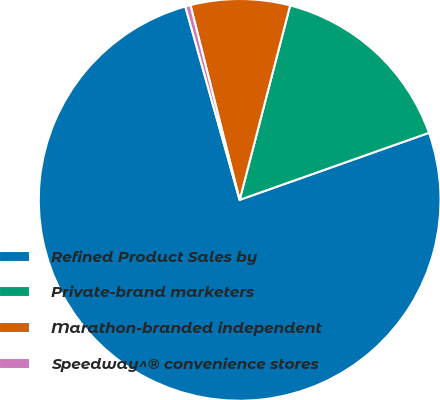<chart> <loc_0><loc_0><loc_500><loc_500><pie_chart><fcel>Refined Product Sales by<fcel>Private-brand marketers<fcel>Marathon-branded independent<fcel>Speedway^® convenience stores<nl><fcel>76.06%<fcel>15.54%<fcel>7.98%<fcel>0.42%<nl></chart> 